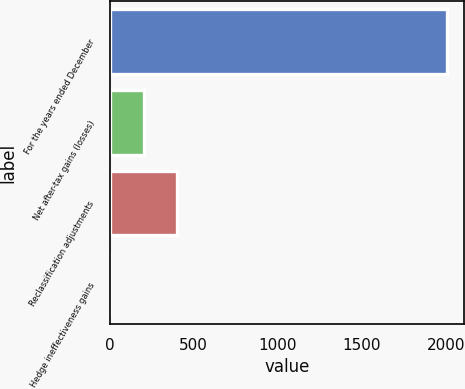Convert chart to OTSL. <chart><loc_0><loc_0><loc_500><loc_500><bar_chart><fcel>For the years ended December<fcel>Net after-tax gains (losses)<fcel>Reclassification adjustments<fcel>Hedge ineffectiveness gains<nl><fcel>2005<fcel>202.3<fcel>402.6<fcel>2<nl></chart> 